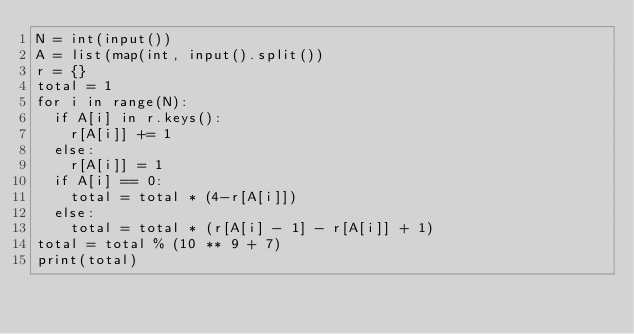Convert code to text. <code><loc_0><loc_0><loc_500><loc_500><_Python_>N = int(input())
A = list(map(int, input().split())
r = {}
total = 1
for i in range(N):
  if A[i] in r.keys():
    r[A[i]] += 1
  else:
    r[A[i]] = 1
  if A[i] == 0:
    total = total * (4-r[A[i]])
  else:
    total = total * (r[A[i] - 1] - r[A[i]] + 1)
total = total % (10 ** 9 + 7)
print(total)</code> 